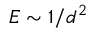<formula> <loc_0><loc_0><loc_500><loc_500>E \sim 1 / d ^ { 2 }</formula> 